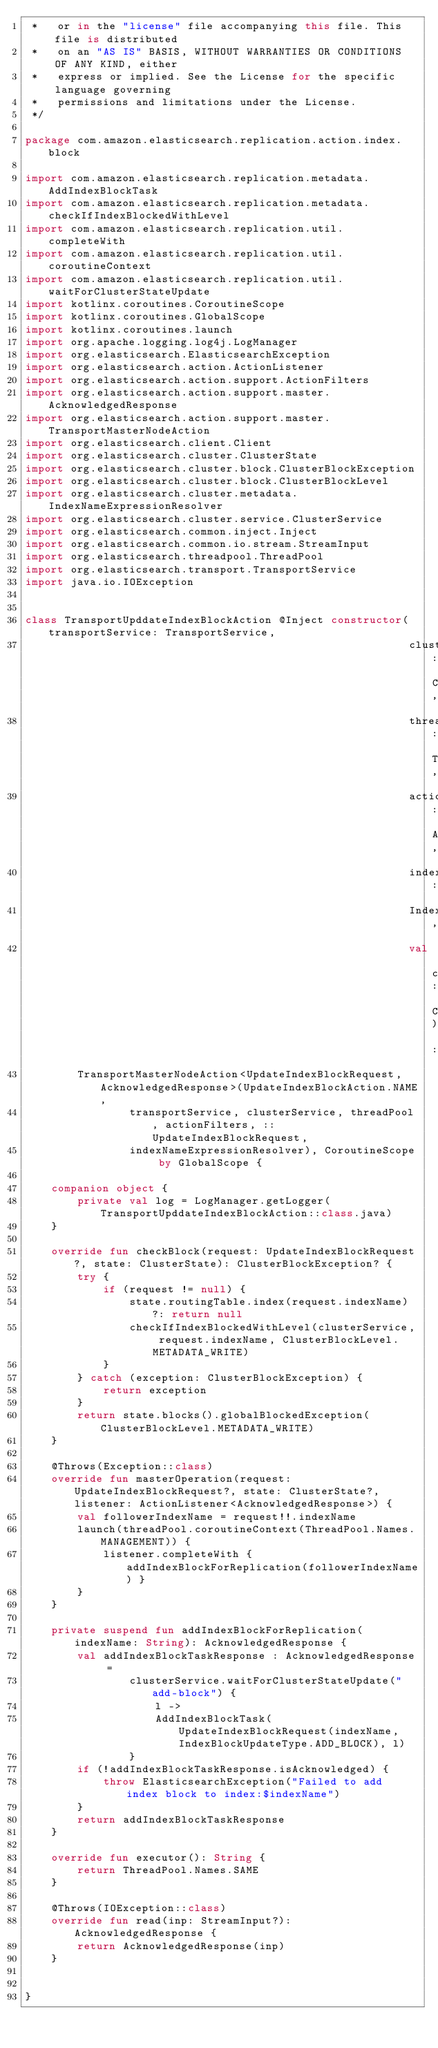Convert code to text. <code><loc_0><loc_0><loc_500><loc_500><_Kotlin_> *   or in the "license" file accompanying this file. This file is distributed
 *   on an "AS IS" BASIS, WITHOUT WARRANTIES OR CONDITIONS OF ANY KIND, either
 *   express or implied. See the License for the specific language governing
 *   permissions and limitations under the License.
 */

package com.amazon.elasticsearch.replication.action.index.block

import com.amazon.elasticsearch.replication.metadata.AddIndexBlockTask
import com.amazon.elasticsearch.replication.metadata.checkIfIndexBlockedWithLevel
import com.amazon.elasticsearch.replication.util.completeWith
import com.amazon.elasticsearch.replication.util.coroutineContext
import com.amazon.elasticsearch.replication.util.waitForClusterStateUpdate
import kotlinx.coroutines.CoroutineScope
import kotlinx.coroutines.GlobalScope
import kotlinx.coroutines.launch
import org.apache.logging.log4j.LogManager
import org.elasticsearch.ElasticsearchException
import org.elasticsearch.action.ActionListener
import org.elasticsearch.action.support.ActionFilters
import org.elasticsearch.action.support.master.AcknowledgedResponse
import org.elasticsearch.action.support.master.TransportMasterNodeAction
import org.elasticsearch.client.Client
import org.elasticsearch.cluster.ClusterState
import org.elasticsearch.cluster.block.ClusterBlockException
import org.elasticsearch.cluster.block.ClusterBlockLevel
import org.elasticsearch.cluster.metadata.IndexNameExpressionResolver
import org.elasticsearch.cluster.service.ClusterService
import org.elasticsearch.common.inject.Inject
import org.elasticsearch.common.io.stream.StreamInput
import org.elasticsearch.threadpool.ThreadPool
import org.elasticsearch.transport.TransportService
import java.io.IOException


class TransportUpddateIndexBlockAction @Inject constructor(transportService: TransportService,
                                                           clusterService: ClusterService,
                                                           threadPool: ThreadPool,
                                                           actionFilters: ActionFilters,
                                                           indexNameExpressionResolver:
                                                           IndexNameExpressionResolver,
                                                           val client: Client) :
        TransportMasterNodeAction<UpdateIndexBlockRequest, AcknowledgedResponse>(UpdateIndexBlockAction.NAME,
                transportService, clusterService, threadPool, actionFilters, ::UpdateIndexBlockRequest,
                indexNameExpressionResolver), CoroutineScope by GlobalScope {

    companion object {
        private val log = LogManager.getLogger(TransportUpddateIndexBlockAction::class.java)
    }

    override fun checkBlock(request: UpdateIndexBlockRequest?, state: ClusterState): ClusterBlockException? {
        try {
            if (request != null) {
                state.routingTable.index(request.indexName) ?: return null
                checkIfIndexBlockedWithLevel(clusterService, request.indexName, ClusterBlockLevel.METADATA_WRITE)
            }
        } catch (exception: ClusterBlockException) {
            return exception
        }
        return state.blocks().globalBlockedException(ClusterBlockLevel.METADATA_WRITE)
    }

    @Throws(Exception::class)
    override fun masterOperation(request: UpdateIndexBlockRequest?, state: ClusterState?, listener: ActionListener<AcknowledgedResponse>) {
        val followerIndexName = request!!.indexName
        launch(threadPool.coroutineContext(ThreadPool.Names.MANAGEMENT)) {
            listener.completeWith { addIndexBlockForReplication(followerIndexName) }
        }
    }

    private suspend fun addIndexBlockForReplication(indexName: String): AcknowledgedResponse {
        val addIndexBlockTaskResponse : AcknowledgedResponse =
                clusterService.waitForClusterStateUpdate("add-block") {
                    l ->
                    AddIndexBlockTask(UpdateIndexBlockRequest(indexName, IndexBlockUpdateType.ADD_BLOCK), l)
                }
        if (!addIndexBlockTaskResponse.isAcknowledged) {
            throw ElasticsearchException("Failed to add index block to index:$indexName")
        }
        return addIndexBlockTaskResponse
    }

    override fun executor(): String {
        return ThreadPool.Names.SAME
    }

    @Throws(IOException::class)
    override fun read(inp: StreamInput?): AcknowledgedResponse {
        return AcknowledgedResponse(inp)
    }


}
</code> 